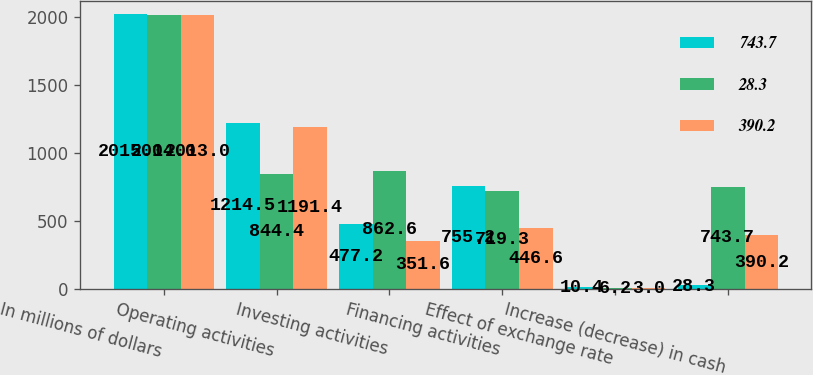Convert chart. <chart><loc_0><loc_0><loc_500><loc_500><stacked_bar_chart><ecel><fcel>In millions of dollars<fcel>Operating activities<fcel>Investing activities<fcel>Financing activities<fcel>Effect of exchange rate<fcel>Increase (decrease) in cash<nl><fcel>743.7<fcel>2015<fcel>1214.5<fcel>477.2<fcel>755.2<fcel>10.4<fcel>28.3<nl><fcel>28.3<fcel>2014<fcel>844.4<fcel>862.6<fcel>719.3<fcel>6.2<fcel>743.7<nl><fcel>390.2<fcel>2013<fcel>1191.4<fcel>351.6<fcel>446.6<fcel>3<fcel>390.2<nl></chart> 